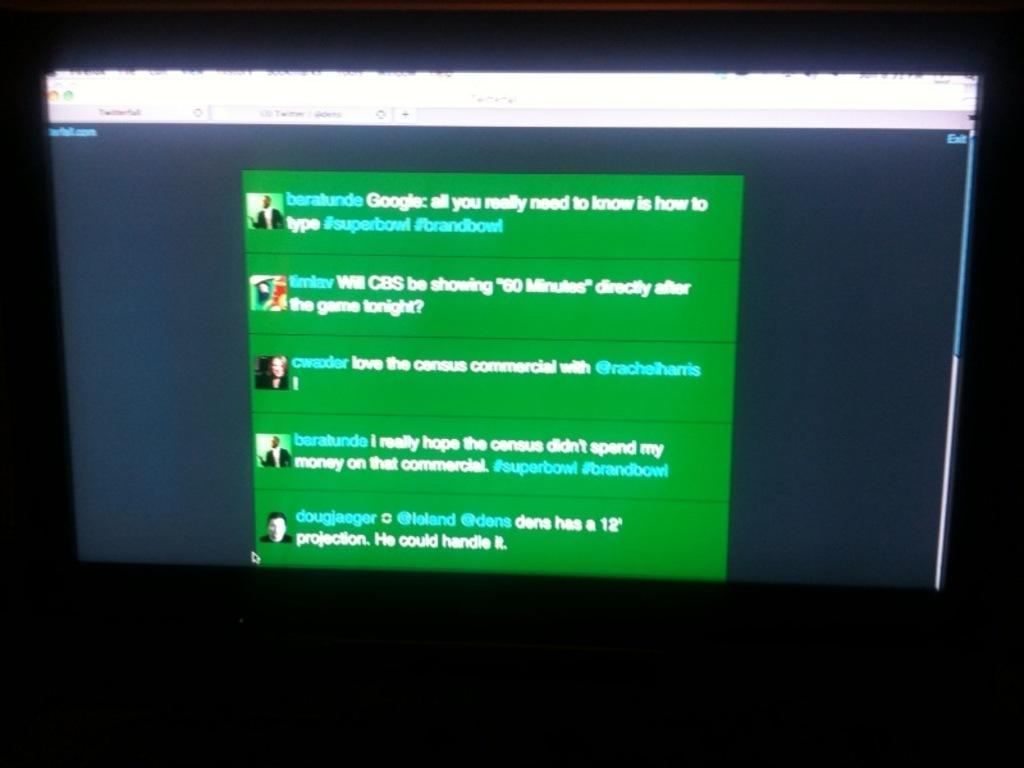<image>
Offer a succinct explanation of the picture presented. A computer screen is showing an online conversation between Baralunde, timlav, and some other people. 